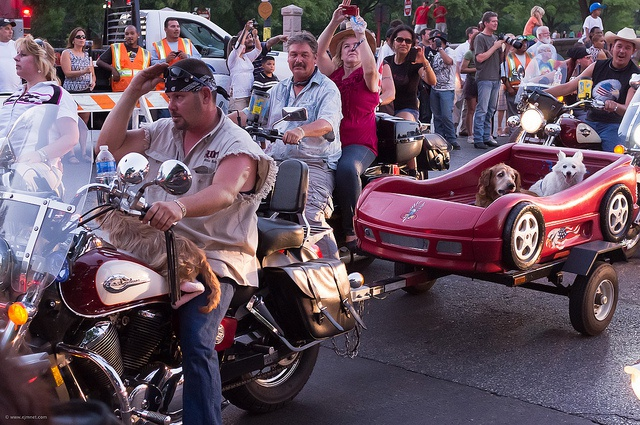Describe the objects in this image and their specific colors. I can see motorcycle in purple, black, gray, lightgray, and darkgray tones, car in purple, black, maroon, lightgray, and gray tones, people in purple, black, brown, and darkgray tones, people in purple, black, gray, lavender, and navy tones, and people in purple, lavender, darkgray, and pink tones in this image. 